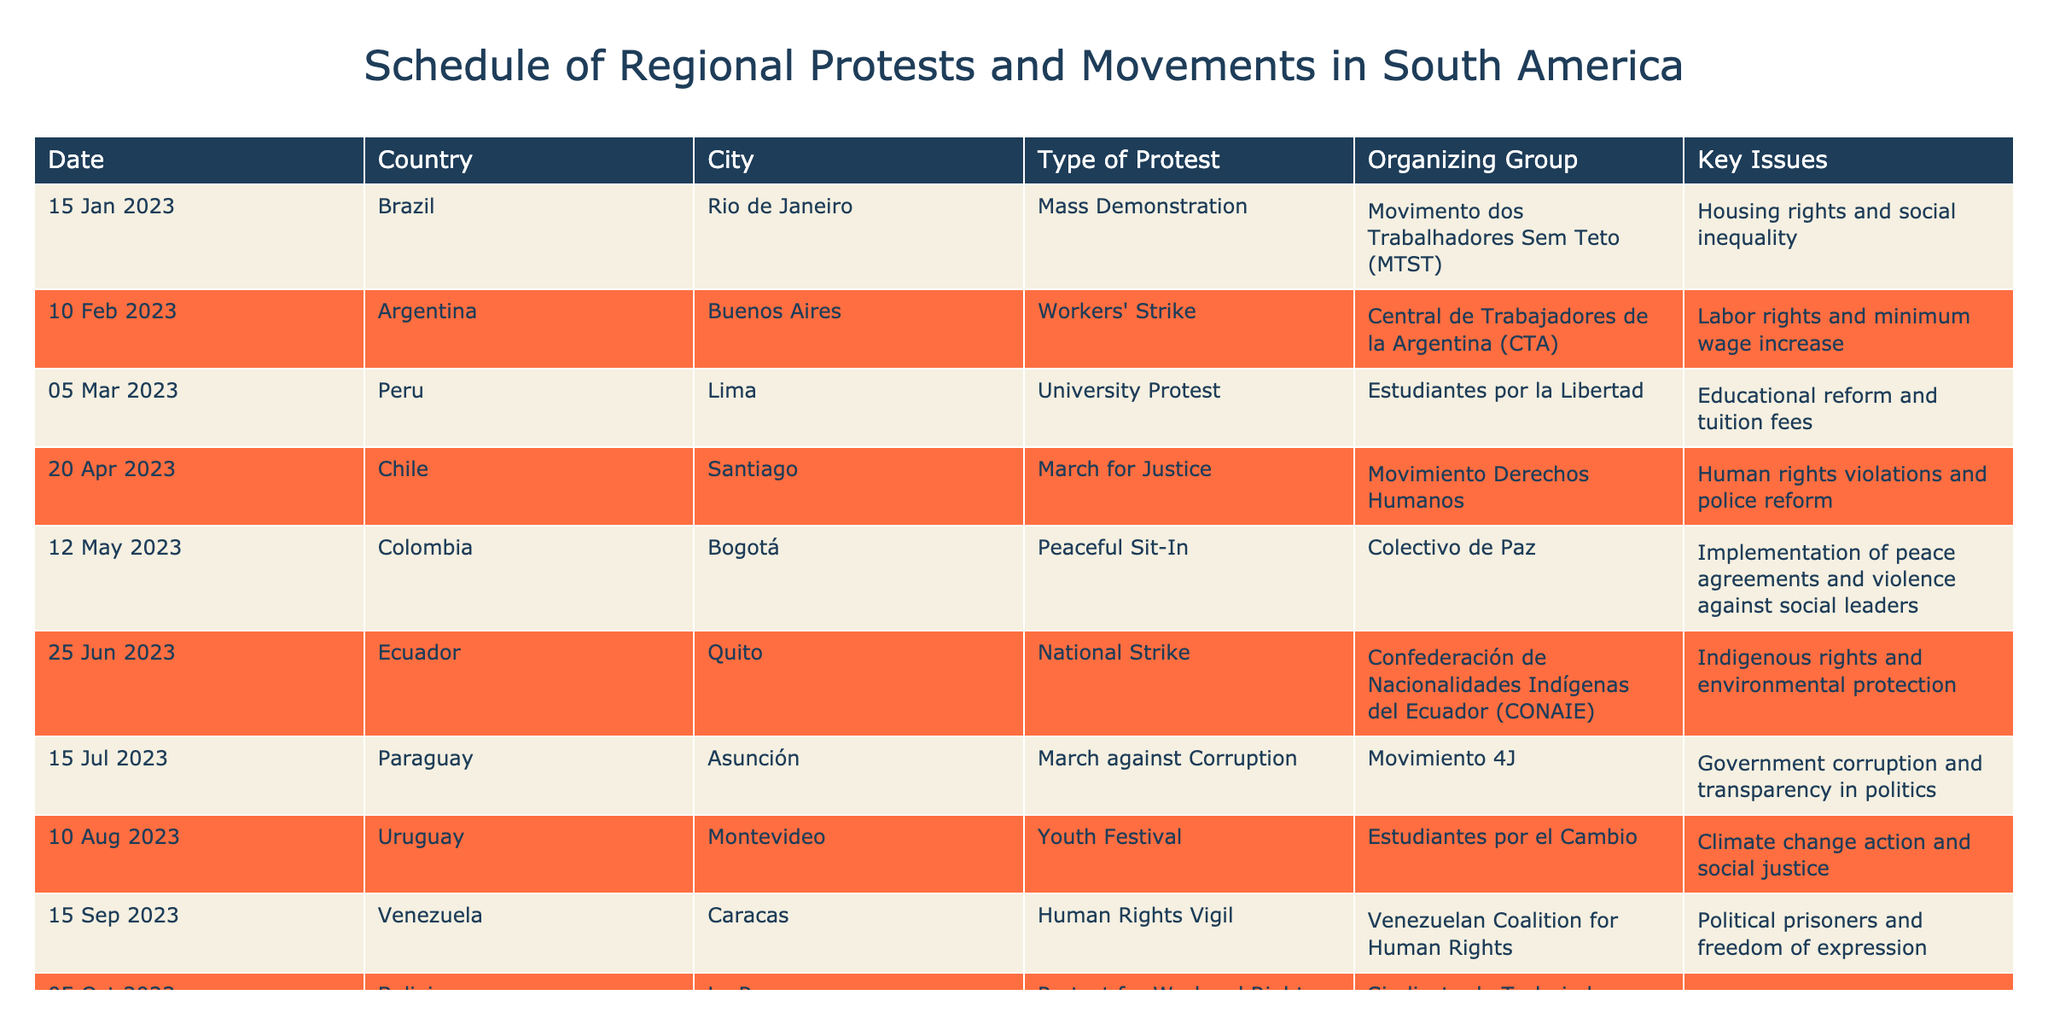What type of protest occurred in Montevideo, Uruguay? The table shows that on August 10, 2023, there was a Youth Festival in Montevideo, Uruguay.
Answer: Youth Festival Which organizing group led the protest in Bogotá, Colombia? According to the table, the peaceful sit-in in Bogotá was organized by Colectivo de Paz.
Answer: Colectivo de Paz What were the key issues raised during the national strike in Quito, Ecuador? The table indicates that the key issues during the national strike on June 25, 2023, were Indigenous rights and environmental protection.
Answer: Indigenous rights and environmental protection How many protests focused on human rights issues? By inspecting the table, there are two protests that focus specifically on human rights issues: the March for Justice in Santiago and the Human Rights Vigil in Caracas. Therefore, the total is 2.
Answer: 2 Was there a protest related to climate change in the table? The information in the table confirms that the Youth Festival in Montevideo dealt with climate change action and social justice, so the answer is yes.
Answer: Yes What was the date of the protest for workers' rights in La Paz, Bolivia? The table clearly states that the protest for workers' rights took place on October 5, 2023.
Answer: October 5, 2023 Which country had the latest reported protest and what was it about? The table shows that the latest reported protest was in Bolivia on October 5, 2023, and it was about opposition to labor law reforms and wage decrease.
Answer: Bolivia, opposition to labor law reforms and wage decrease Find the number of protests concerning labor rights. From the table, there are three protests related to labor rights: the workers' strike in Buenos Aires, the protest for workers' rights in La Paz, and the peaceful sit-in in Bogotá, making it a total of 3.
Answer: 3 What were the issues raised during the protest in Rio de Janeiro, Brazil? The table lists that the key issues during the mass demonstration in Rio de Janeiro on January 15, 2023, were housing rights and social inequality.
Answer: Housing rights and social inequality 